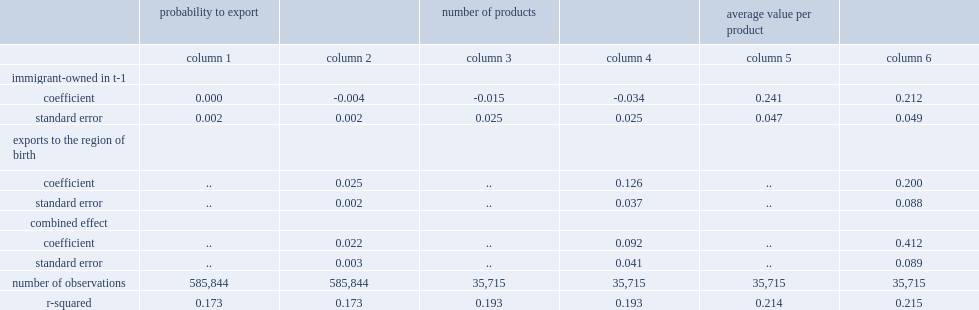How many percentage points is the probability of immigrant-owned firms exporting to immigrant owners' regions of origin higher than that of canadian-owned firms? 0.022. How many percentage points is the probability of exporting to other regions? 0.004. 